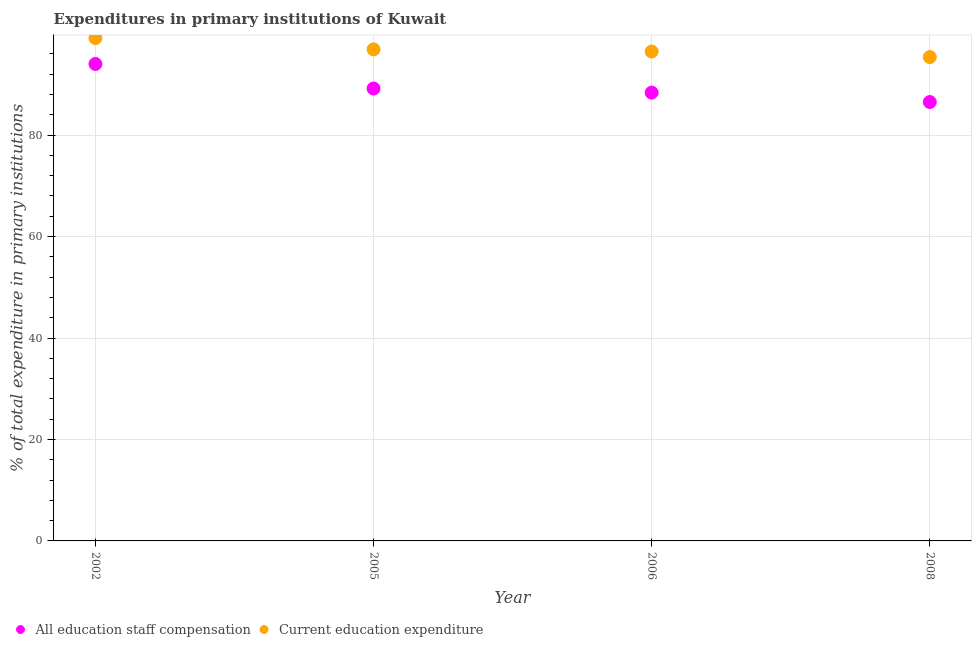Is the number of dotlines equal to the number of legend labels?
Keep it short and to the point. Yes. What is the expenditure in staff compensation in 2005?
Your response must be concise. 89.19. Across all years, what is the maximum expenditure in staff compensation?
Your answer should be compact. 94.02. Across all years, what is the minimum expenditure in staff compensation?
Provide a short and direct response. 86.52. What is the total expenditure in education in the graph?
Offer a terse response. 387.88. What is the difference between the expenditure in staff compensation in 2002 and that in 2005?
Make the answer very short. 4.84. What is the difference between the expenditure in staff compensation in 2006 and the expenditure in education in 2005?
Ensure brevity in your answer.  -8.53. What is the average expenditure in education per year?
Ensure brevity in your answer.  96.97. In the year 2008, what is the difference between the expenditure in education and expenditure in staff compensation?
Your response must be concise. 8.86. What is the ratio of the expenditure in staff compensation in 2006 to that in 2008?
Offer a very short reply. 1.02. Is the expenditure in education in 2002 less than that in 2006?
Your response must be concise. No. Is the difference between the expenditure in education in 2005 and 2006 greater than the difference between the expenditure in staff compensation in 2005 and 2006?
Provide a succinct answer. No. What is the difference between the highest and the second highest expenditure in staff compensation?
Your response must be concise. 4.84. What is the difference between the highest and the lowest expenditure in staff compensation?
Provide a succinct answer. 7.5. In how many years, is the expenditure in education greater than the average expenditure in education taken over all years?
Your answer should be very brief. 1. Does the expenditure in staff compensation monotonically increase over the years?
Your answer should be very brief. No. What is the difference between two consecutive major ticks on the Y-axis?
Your answer should be very brief. 20. Are the values on the major ticks of Y-axis written in scientific E-notation?
Offer a very short reply. No. Does the graph contain any zero values?
Provide a short and direct response. No. Where does the legend appear in the graph?
Your response must be concise. Bottom left. What is the title of the graph?
Your answer should be very brief. Expenditures in primary institutions of Kuwait. What is the label or title of the X-axis?
Provide a succinct answer. Year. What is the label or title of the Y-axis?
Your answer should be very brief. % of total expenditure in primary institutions. What is the % of total expenditure in primary institutions in All education staff compensation in 2002?
Your answer should be compact. 94.02. What is the % of total expenditure in primary institutions in Current education expenditure in 2002?
Provide a succinct answer. 99.13. What is the % of total expenditure in primary institutions of All education staff compensation in 2005?
Make the answer very short. 89.19. What is the % of total expenditure in primary institutions in Current education expenditure in 2005?
Your response must be concise. 96.9. What is the % of total expenditure in primary institutions of All education staff compensation in 2006?
Your answer should be compact. 88.37. What is the % of total expenditure in primary institutions in Current education expenditure in 2006?
Your response must be concise. 96.47. What is the % of total expenditure in primary institutions of All education staff compensation in 2008?
Ensure brevity in your answer.  86.52. What is the % of total expenditure in primary institutions of Current education expenditure in 2008?
Provide a succinct answer. 95.38. Across all years, what is the maximum % of total expenditure in primary institutions in All education staff compensation?
Your response must be concise. 94.02. Across all years, what is the maximum % of total expenditure in primary institutions of Current education expenditure?
Ensure brevity in your answer.  99.13. Across all years, what is the minimum % of total expenditure in primary institutions in All education staff compensation?
Give a very brief answer. 86.52. Across all years, what is the minimum % of total expenditure in primary institutions in Current education expenditure?
Your answer should be compact. 95.38. What is the total % of total expenditure in primary institutions of All education staff compensation in the graph?
Your answer should be very brief. 358.1. What is the total % of total expenditure in primary institutions in Current education expenditure in the graph?
Ensure brevity in your answer.  387.88. What is the difference between the % of total expenditure in primary institutions in All education staff compensation in 2002 and that in 2005?
Make the answer very short. 4.84. What is the difference between the % of total expenditure in primary institutions in Current education expenditure in 2002 and that in 2005?
Your answer should be compact. 2.22. What is the difference between the % of total expenditure in primary institutions in All education staff compensation in 2002 and that in 2006?
Your answer should be compact. 5.65. What is the difference between the % of total expenditure in primary institutions of Current education expenditure in 2002 and that in 2006?
Offer a terse response. 2.66. What is the difference between the % of total expenditure in primary institutions of All education staff compensation in 2002 and that in 2008?
Offer a very short reply. 7.5. What is the difference between the % of total expenditure in primary institutions of Current education expenditure in 2002 and that in 2008?
Your answer should be compact. 3.75. What is the difference between the % of total expenditure in primary institutions in All education staff compensation in 2005 and that in 2006?
Keep it short and to the point. 0.81. What is the difference between the % of total expenditure in primary institutions in Current education expenditure in 2005 and that in 2006?
Your answer should be very brief. 0.43. What is the difference between the % of total expenditure in primary institutions in All education staff compensation in 2005 and that in 2008?
Offer a very short reply. 2.67. What is the difference between the % of total expenditure in primary institutions of Current education expenditure in 2005 and that in 2008?
Your answer should be compact. 1.52. What is the difference between the % of total expenditure in primary institutions of All education staff compensation in 2006 and that in 2008?
Offer a terse response. 1.85. What is the difference between the % of total expenditure in primary institutions in Current education expenditure in 2006 and that in 2008?
Provide a short and direct response. 1.09. What is the difference between the % of total expenditure in primary institutions in All education staff compensation in 2002 and the % of total expenditure in primary institutions in Current education expenditure in 2005?
Your answer should be compact. -2.88. What is the difference between the % of total expenditure in primary institutions of All education staff compensation in 2002 and the % of total expenditure in primary institutions of Current education expenditure in 2006?
Provide a short and direct response. -2.45. What is the difference between the % of total expenditure in primary institutions of All education staff compensation in 2002 and the % of total expenditure in primary institutions of Current education expenditure in 2008?
Give a very brief answer. -1.36. What is the difference between the % of total expenditure in primary institutions in All education staff compensation in 2005 and the % of total expenditure in primary institutions in Current education expenditure in 2006?
Keep it short and to the point. -7.28. What is the difference between the % of total expenditure in primary institutions of All education staff compensation in 2005 and the % of total expenditure in primary institutions of Current education expenditure in 2008?
Offer a terse response. -6.19. What is the difference between the % of total expenditure in primary institutions in All education staff compensation in 2006 and the % of total expenditure in primary institutions in Current education expenditure in 2008?
Keep it short and to the point. -7.01. What is the average % of total expenditure in primary institutions in All education staff compensation per year?
Provide a succinct answer. 89.52. What is the average % of total expenditure in primary institutions in Current education expenditure per year?
Offer a very short reply. 96.97. In the year 2002, what is the difference between the % of total expenditure in primary institutions in All education staff compensation and % of total expenditure in primary institutions in Current education expenditure?
Your response must be concise. -5.1. In the year 2005, what is the difference between the % of total expenditure in primary institutions of All education staff compensation and % of total expenditure in primary institutions of Current education expenditure?
Ensure brevity in your answer.  -7.72. In the year 2006, what is the difference between the % of total expenditure in primary institutions in All education staff compensation and % of total expenditure in primary institutions in Current education expenditure?
Keep it short and to the point. -8.1. In the year 2008, what is the difference between the % of total expenditure in primary institutions in All education staff compensation and % of total expenditure in primary institutions in Current education expenditure?
Your answer should be very brief. -8.86. What is the ratio of the % of total expenditure in primary institutions of All education staff compensation in 2002 to that in 2005?
Give a very brief answer. 1.05. What is the ratio of the % of total expenditure in primary institutions of All education staff compensation in 2002 to that in 2006?
Make the answer very short. 1.06. What is the ratio of the % of total expenditure in primary institutions of Current education expenditure in 2002 to that in 2006?
Give a very brief answer. 1.03. What is the ratio of the % of total expenditure in primary institutions of All education staff compensation in 2002 to that in 2008?
Provide a short and direct response. 1.09. What is the ratio of the % of total expenditure in primary institutions of Current education expenditure in 2002 to that in 2008?
Keep it short and to the point. 1.04. What is the ratio of the % of total expenditure in primary institutions in All education staff compensation in 2005 to that in 2006?
Offer a terse response. 1.01. What is the ratio of the % of total expenditure in primary institutions of All education staff compensation in 2005 to that in 2008?
Offer a terse response. 1.03. What is the ratio of the % of total expenditure in primary institutions of All education staff compensation in 2006 to that in 2008?
Provide a short and direct response. 1.02. What is the ratio of the % of total expenditure in primary institutions in Current education expenditure in 2006 to that in 2008?
Offer a very short reply. 1.01. What is the difference between the highest and the second highest % of total expenditure in primary institutions in All education staff compensation?
Offer a very short reply. 4.84. What is the difference between the highest and the second highest % of total expenditure in primary institutions in Current education expenditure?
Provide a short and direct response. 2.22. What is the difference between the highest and the lowest % of total expenditure in primary institutions in All education staff compensation?
Offer a terse response. 7.5. What is the difference between the highest and the lowest % of total expenditure in primary institutions of Current education expenditure?
Give a very brief answer. 3.75. 